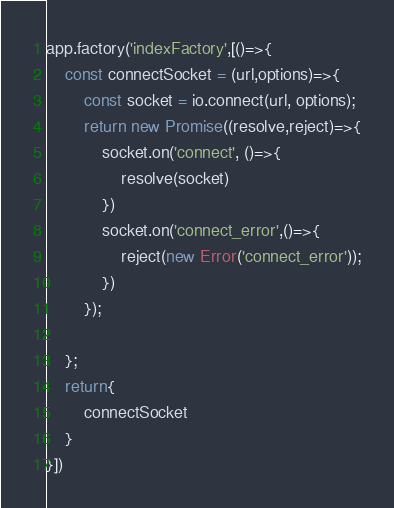Convert code to text. <code><loc_0><loc_0><loc_500><loc_500><_JavaScript_>app.factory('indexFactory',[()=>{
    const connectSocket = (url,options)=>{
        const socket = io.connect(url, options);
        return new Promise((resolve,reject)=>{
            socket.on('connect', ()=>{
                resolve(socket)
            })
            socket.on('connect_error',()=>{
                reject(new Error('connect_error'));
            })
        });

    };
    return{
        connectSocket
    }
}])</code> 